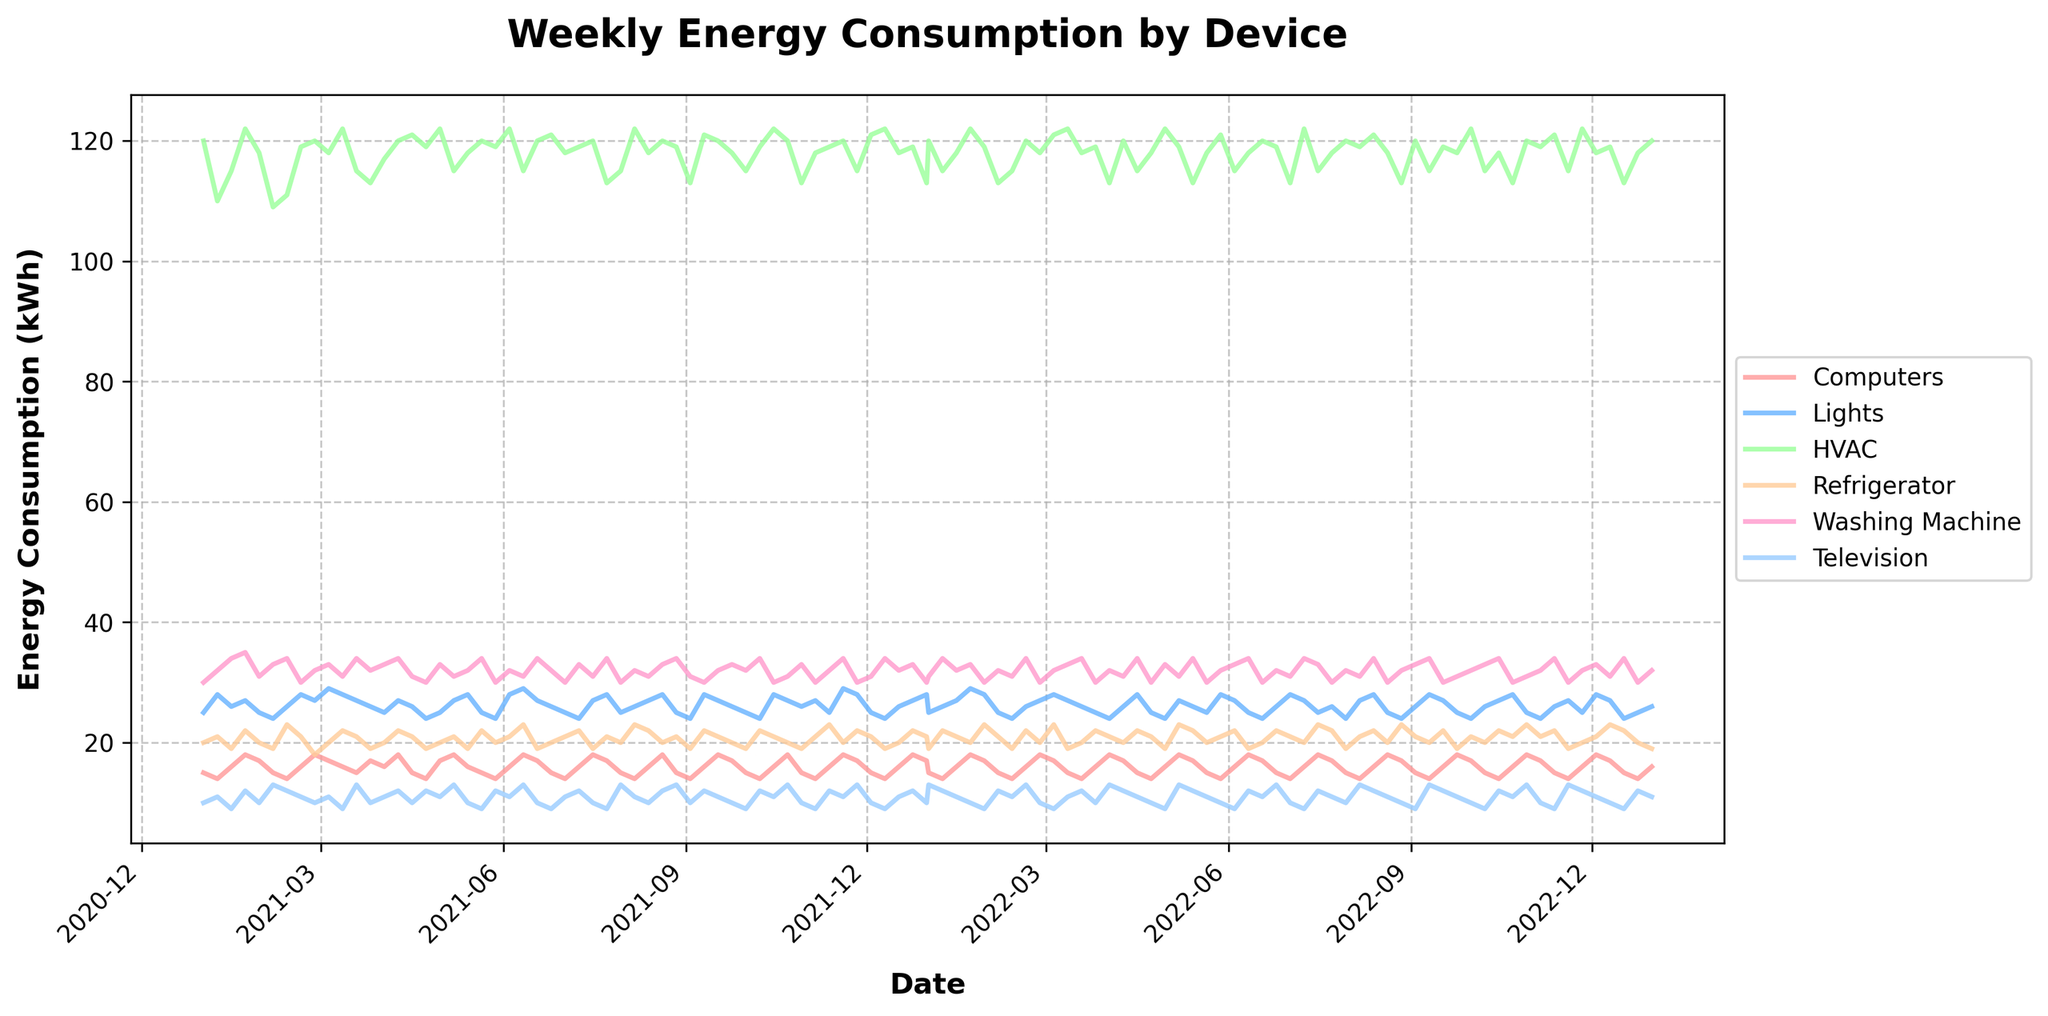what is the title of the plot? The title of the plot is usually placed at the top center of the figure. In this case, it reads 'Weekly Energy Consumption by Device'.
Answer: Weekly Energy Consumption by Device Which device shows the highest energy consumption on average? To determine which device has the highest average energy consumption, visually compare the lines on the plot. The HVAC line consistently appears higher than the others on the y-axis.
Answer: HVAC How does the energy consumption of Lights in April 2021 compare to that in April 2022? To compare, look at the plot for the month of April in both years. In April 2021, Lights consumption is around 25-28 kWh, while in April 2022, it is generally more fluctuating but around 24-28 kWh as well. The trend seems fairly consistent.
Answer: Similar During which months does the Washing Machine show a peak in energy consumption? The visual inspection shows peaks on the line representing Washing Machine. Particularly notable spikes are observed in January and July.
Answer: January and July What is the overall trend of the HVAC energy consumption over the two years? Observing the HVAC line across the entire plot shows an overall consistent trend without significant variation, staying relatively stable between approximately 113 and 122 kWh.
Answer: Stable Which device has the most variability in energy consumption over time? Variability is seen where the line fluctuates the most on the plot. The HVAC line fluctuates moderately but remains within a consistent range, whereas Washing Machine and Television show more frequent and larger changes, with the Washing Machine appearing most variable.
Answer: Washing Machine How did the Refrigerator’s energy consumption trend from January to December of 2022? Trace the line for the Refrigerator from January to December of 2022. The consumption remains relatively stable with slight increases and decreases but does not show any extreme peaks or drops, maintaining an average around 19-23 kWh.
Answer: Stable Which device's energy consumption showed a decrease from May to September 2022? Look at the period from May to September 2022. The energy consumption for HVAC decreases from around 121 kWh in May to about 113 kWh by September.
Answer: HVAC 